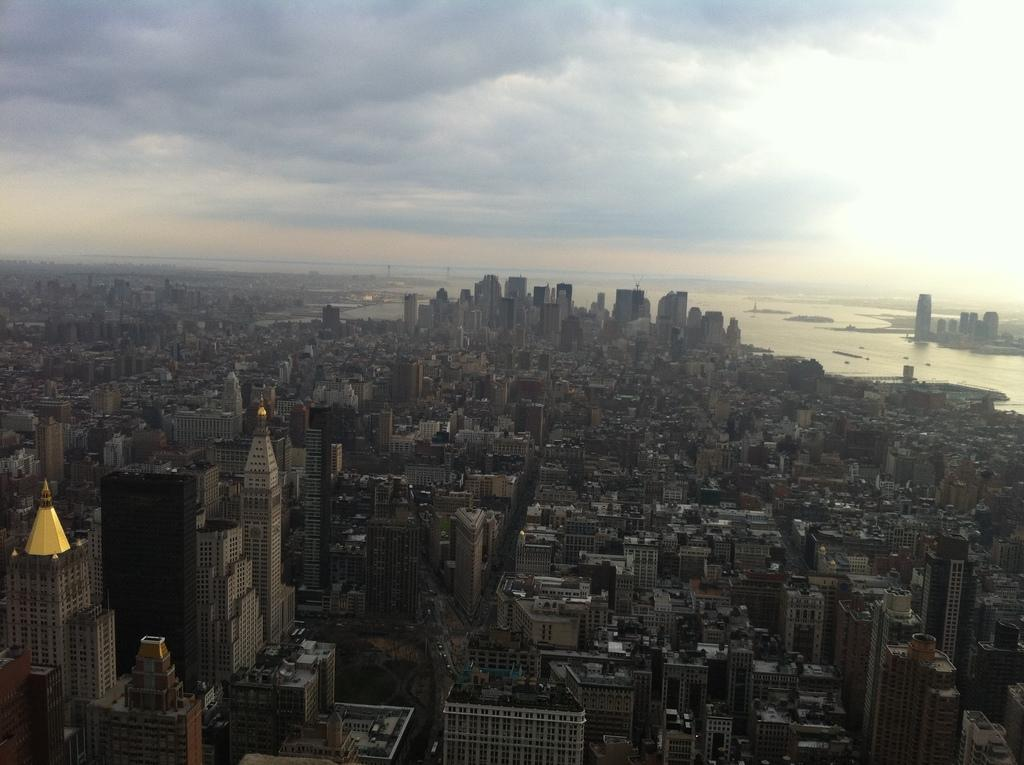What type of view is shown in the image? The image is a top view of the city. What structures can be seen in the image? There are buildings in the image. What natural feature is present in the image? There is a river in the image. What is visible at the top of the image? The sky is visible at the top of the image. What can be observed in the sky? There are clouds in the sky. How does the cream affect the self in the image? There is no cream or self present in the image. What type of cough can be heard coming from the buildings in the image? There is no sound, including coughing, depicted in the image. 